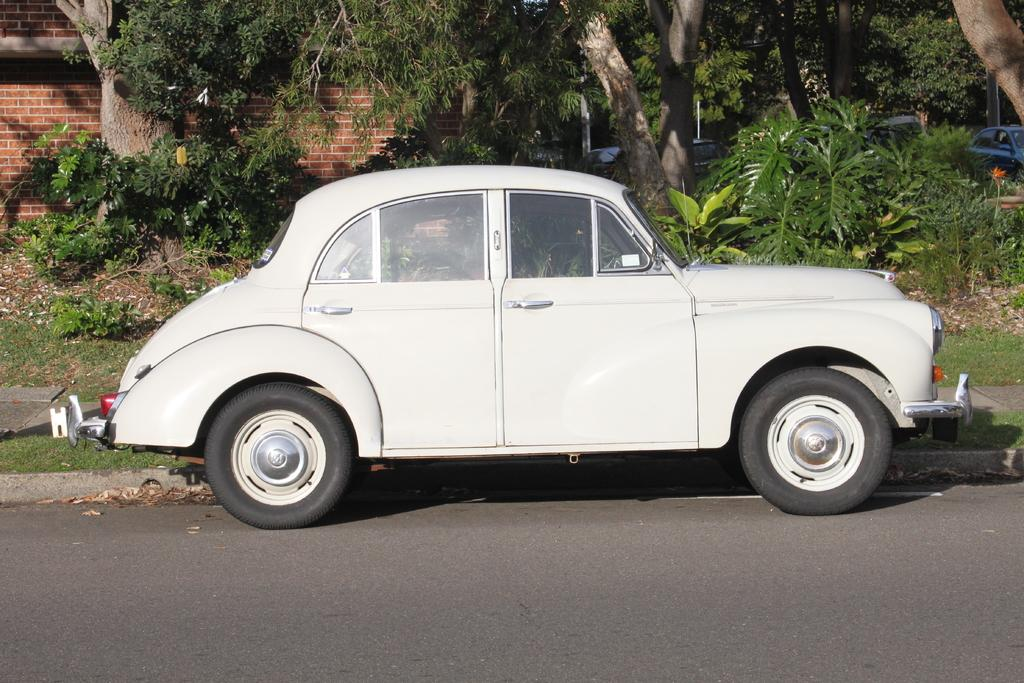What is the main subject in the center of the image? There is a car in the center of the image. Where is the car located? The car is on the road. What can be seen in the background of the image? There are trees and a house in the background of the image. Are there any other vehicles visible in the image? Yes, there are vehicles in the background of the image. What type of meat is the scarecrow holding in the image? There is no scarecrow or meat present in the image. How many chickens can be seen in the image? There are no chickens present in the image. 